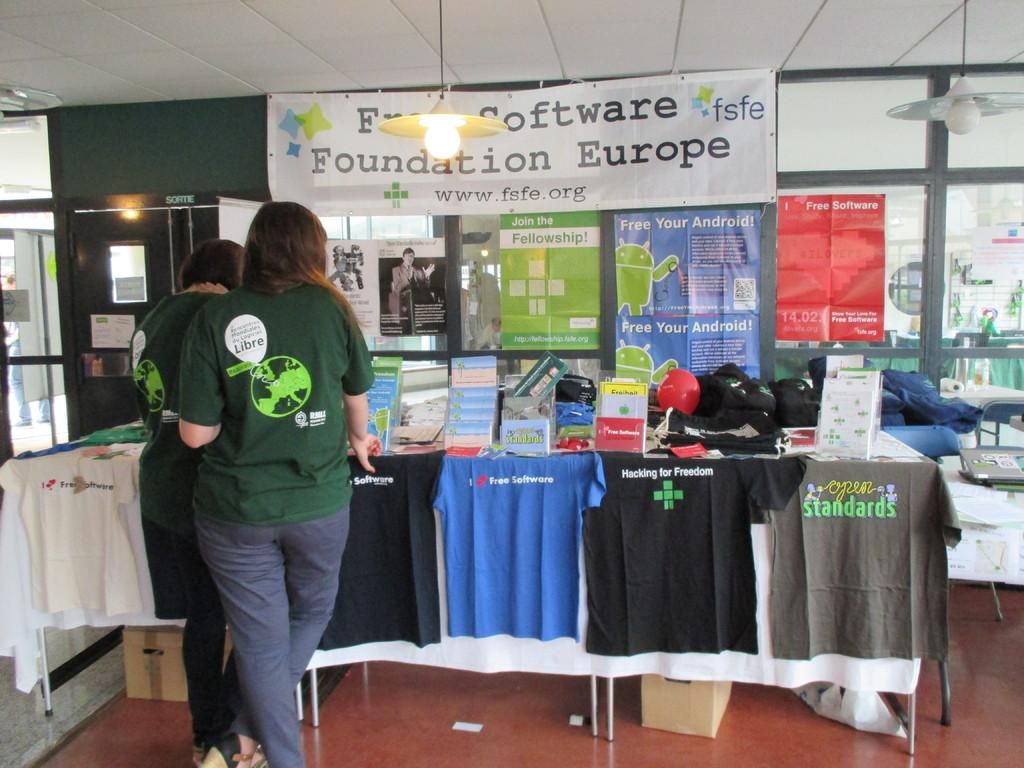<image>
Offer a succinct explanation of the picture presented. a white sign that has foundation europe written on it in a conference hall 